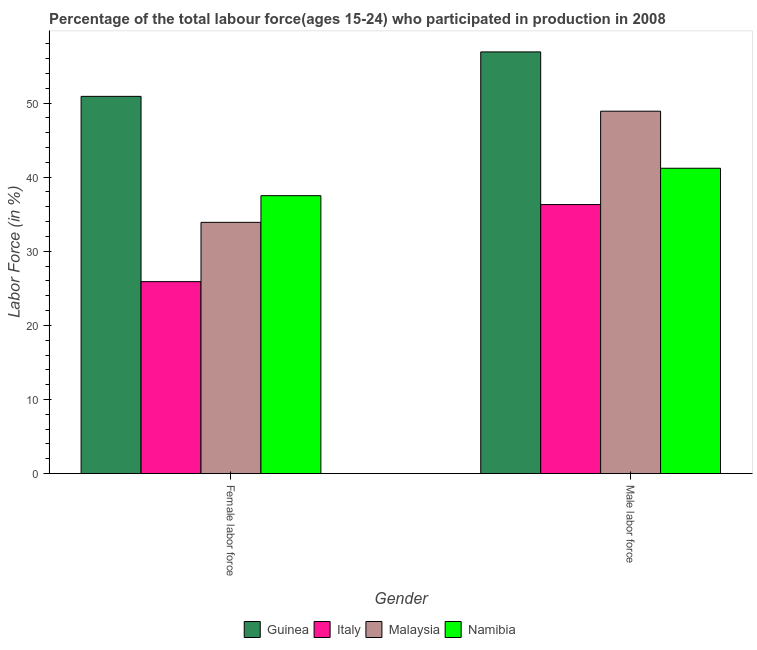How many groups of bars are there?
Your answer should be compact. 2. Are the number of bars on each tick of the X-axis equal?
Keep it short and to the point. Yes. How many bars are there on the 1st tick from the left?
Ensure brevity in your answer.  4. What is the label of the 1st group of bars from the left?
Provide a succinct answer. Female labor force. What is the percentage of male labour force in Italy?
Give a very brief answer. 36.3. Across all countries, what is the maximum percentage of female labor force?
Offer a very short reply. 50.9. Across all countries, what is the minimum percentage of female labor force?
Provide a short and direct response. 25.9. In which country was the percentage of male labour force maximum?
Offer a terse response. Guinea. What is the total percentage of female labor force in the graph?
Your answer should be very brief. 148.2. What is the difference between the percentage of male labour force in Malaysia and that in Italy?
Provide a short and direct response. 12.6. What is the difference between the percentage of female labor force in Guinea and the percentage of male labour force in Italy?
Ensure brevity in your answer.  14.6. What is the average percentage of female labor force per country?
Keep it short and to the point. 37.05. What is the difference between the percentage of male labour force and percentage of female labor force in Namibia?
Your answer should be compact. 3.7. What is the ratio of the percentage of female labor force in Malaysia to that in Namibia?
Keep it short and to the point. 0.9. In how many countries, is the percentage of female labor force greater than the average percentage of female labor force taken over all countries?
Give a very brief answer. 2. What does the 1st bar from the left in Male labor force represents?
Your response must be concise. Guinea. What does the 4th bar from the right in Female labor force represents?
Keep it short and to the point. Guinea. How many bars are there?
Ensure brevity in your answer.  8. Are all the bars in the graph horizontal?
Offer a terse response. No. How many countries are there in the graph?
Offer a terse response. 4. Are the values on the major ticks of Y-axis written in scientific E-notation?
Your answer should be very brief. No. Does the graph contain grids?
Make the answer very short. No. How are the legend labels stacked?
Your response must be concise. Horizontal. What is the title of the graph?
Offer a terse response. Percentage of the total labour force(ages 15-24) who participated in production in 2008. What is the label or title of the Y-axis?
Provide a succinct answer. Labor Force (in %). What is the Labor Force (in %) of Guinea in Female labor force?
Your answer should be compact. 50.9. What is the Labor Force (in %) of Italy in Female labor force?
Make the answer very short. 25.9. What is the Labor Force (in %) in Malaysia in Female labor force?
Offer a terse response. 33.9. What is the Labor Force (in %) in Namibia in Female labor force?
Offer a terse response. 37.5. What is the Labor Force (in %) in Guinea in Male labor force?
Keep it short and to the point. 56.9. What is the Labor Force (in %) in Italy in Male labor force?
Provide a succinct answer. 36.3. What is the Labor Force (in %) in Malaysia in Male labor force?
Your answer should be compact. 48.9. What is the Labor Force (in %) of Namibia in Male labor force?
Keep it short and to the point. 41.2. Across all Gender, what is the maximum Labor Force (in %) in Guinea?
Give a very brief answer. 56.9. Across all Gender, what is the maximum Labor Force (in %) in Italy?
Provide a succinct answer. 36.3. Across all Gender, what is the maximum Labor Force (in %) of Malaysia?
Offer a very short reply. 48.9. Across all Gender, what is the maximum Labor Force (in %) in Namibia?
Your answer should be compact. 41.2. Across all Gender, what is the minimum Labor Force (in %) in Guinea?
Make the answer very short. 50.9. Across all Gender, what is the minimum Labor Force (in %) in Italy?
Offer a terse response. 25.9. Across all Gender, what is the minimum Labor Force (in %) of Malaysia?
Provide a succinct answer. 33.9. Across all Gender, what is the minimum Labor Force (in %) in Namibia?
Offer a very short reply. 37.5. What is the total Labor Force (in %) in Guinea in the graph?
Your answer should be very brief. 107.8. What is the total Labor Force (in %) of Italy in the graph?
Offer a very short reply. 62.2. What is the total Labor Force (in %) in Malaysia in the graph?
Keep it short and to the point. 82.8. What is the total Labor Force (in %) of Namibia in the graph?
Provide a short and direct response. 78.7. What is the difference between the Labor Force (in %) in Malaysia in Female labor force and that in Male labor force?
Offer a terse response. -15. What is the difference between the Labor Force (in %) in Guinea in Female labor force and the Labor Force (in %) in Italy in Male labor force?
Give a very brief answer. 14.6. What is the difference between the Labor Force (in %) of Italy in Female labor force and the Labor Force (in %) of Malaysia in Male labor force?
Offer a terse response. -23. What is the difference between the Labor Force (in %) in Italy in Female labor force and the Labor Force (in %) in Namibia in Male labor force?
Provide a succinct answer. -15.3. What is the difference between the Labor Force (in %) of Malaysia in Female labor force and the Labor Force (in %) of Namibia in Male labor force?
Offer a very short reply. -7.3. What is the average Labor Force (in %) of Guinea per Gender?
Ensure brevity in your answer.  53.9. What is the average Labor Force (in %) of Italy per Gender?
Your answer should be compact. 31.1. What is the average Labor Force (in %) of Malaysia per Gender?
Your answer should be compact. 41.4. What is the average Labor Force (in %) in Namibia per Gender?
Make the answer very short. 39.35. What is the difference between the Labor Force (in %) in Guinea and Labor Force (in %) in Italy in Male labor force?
Provide a short and direct response. 20.6. What is the difference between the Labor Force (in %) of Italy and Labor Force (in %) of Malaysia in Male labor force?
Your answer should be compact. -12.6. What is the difference between the Labor Force (in %) of Italy and Labor Force (in %) of Namibia in Male labor force?
Give a very brief answer. -4.9. What is the ratio of the Labor Force (in %) in Guinea in Female labor force to that in Male labor force?
Give a very brief answer. 0.89. What is the ratio of the Labor Force (in %) in Italy in Female labor force to that in Male labor force?
Offer a very short reply. 0.71. What is the ratio of the Labor Force (in %) in Malaysia in Female labor force to that in Male labor force?
Offer a terse response. 0.69. What is the ratio of the Labor Force (in %) in Namibia in Female labor force to that in Male labor force?
Your answer should be compact. 0.91. What is the difference between the highest and the lowest Labor Force (in %) in Guinea?
Provide a short and direct response. 6. What is the difference between the highest and the lowest Labor Force (in %) in Italy?
Provide a short and direct response. 10.4. 